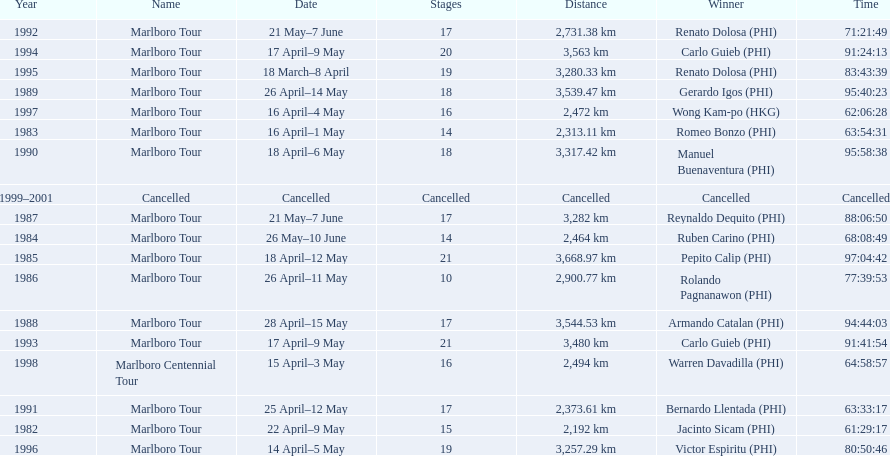What race did warren davadilla compete in in 1998? Marlboro Centennial Tour. How long did it take davadilla to complete the marlboro centennial tour? 64:58:57. 